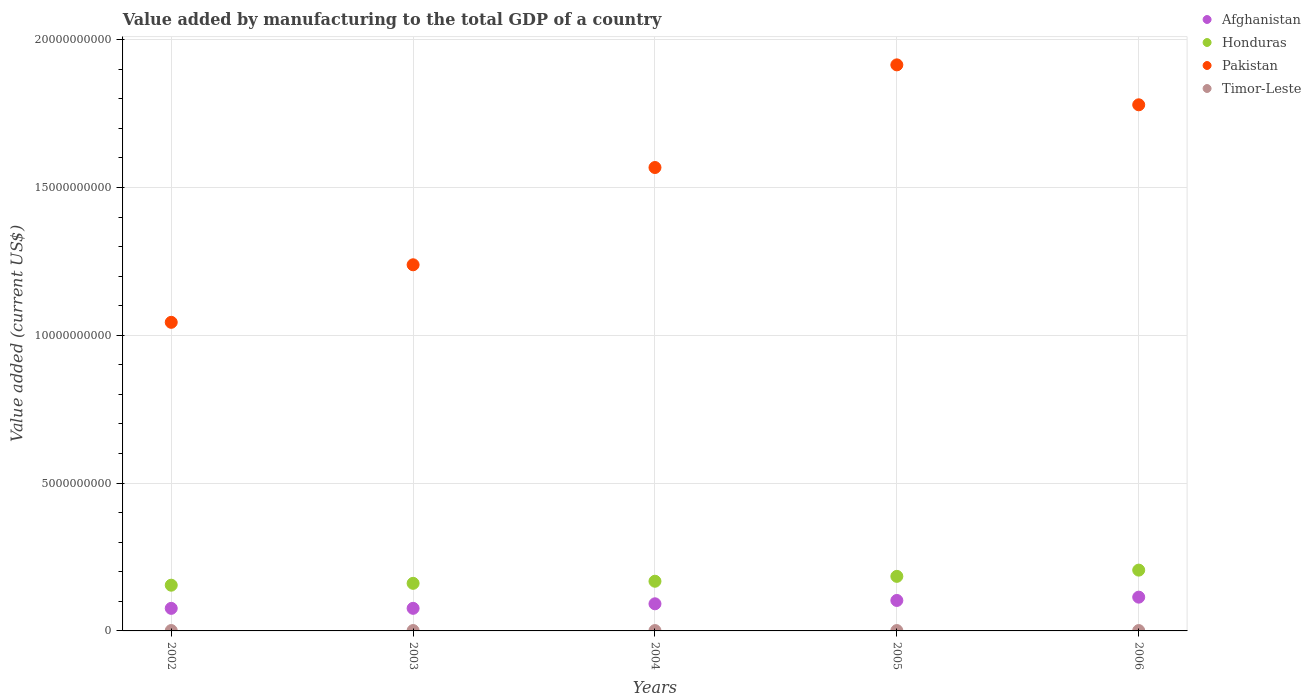How many different coloured dotlines are there?
Your answer should be compact. 4. What is the value added by manufacturing to the total GDP in Afghanistan in 2002?
Ensure brevity in your answer.  7.63e+08. Across all years, what is the maximum value added by manufacturing to the total GDP in Afghanistan?
Your response must be concise. 1.14e+09. Across all years, what is the minimum value added by manufacturing to the total GDP in Pakistan?
Your response must be concise. 1.04e+1. In which year was the value added by manufacturing to the total GDP in Honduras minimum?
Provide a short and direct response. 2002. What is the total value added by manufacturing to the total GDP in Honduras in the graph?
Provide a succinct answer. 8.74e+09. What is the difference between the value added by manufacturing to the total GDP in Pakistan in 2005 and that in 2006?
Your answer should be very brief. 1.35e+09. What is the difference between the value added by manufacturing to the total GDP in Timor-Leste in 2006 and the value added by manufacturing to the total GDP in Pakistan in 2004?
Ensure brevity in your answer.  -1.57e+1. What is the average value added by manufacturing to the total GDP in Pakistan per year?
Offer a terse response. 1.51e+1. In the year 2003, what is the difference between the value added by manufacturing to the total GDP in Pakistan and value added by manufacturing to the total GDP in Honduras?
Provide a succinct answer. 1.08e+1. What is the ratio of the value added by manufacturing to the total GDP in Honduras in 2004 to that in 2005?
Offer a terse response. 0.91. What is the difference between the highest and the lowest value added by manufacturing to the total GDP in Honduras?
Your response must be concise. 5.10e+08. In how many years, is the value added by manufacturing to the total GDP in Afghanistan greater than the average value added by manufacturing to the total GDP in Afghanistan taken over all years?
Give a very brief answer. 2. Is the sum of the value added by manufacturing to the total GDP in Pakistan in 2005 and 2006 greater than the maximum value added by manufacturing to the total GDP in Afghanistan across all years?
Your response must be concise. Yes. Is it the case that in every year, the sum of the value added by manufacturing to the total GDP in Afghanistan and value added by manufacturing to the total GDP in Pakistan  is greater than the sum of value added by manufacturing to the total GDP in Honduras and value added by manufacturing to the total GDP in Timor-Leste?
Make the answer very short. Yes. Is it the case that in every year, the sum of the value added by manufacturing to the total GDP in Pakistan and value added by manufacturing to the total GDP in Timor-Leste  is greater than the value added by manufacturing to the total GDP in Afghanistan?
Your answer should be compact. Yes. Is the value added by manufacturing to the total GDP in Honduras strictly greater than the value added by manufacturing to the total GDP in Pakistan over the years?
Offer a terse response. No. Is the value added by manufacturing to the total GDP in Timor-Leste strictly less than the value added by manufacturing to the total GDP in Pakistan over the years?
Offer a terse response. Yes. How many years are there in the graph?
Your response must be concise. 5. Are the values on the major ticks of Y-axis written in scientific E-notation?
Make the answer very short. No. Does the graph contain grids?
Your answer should be very brief. Yes. How are the legend labels stacked?
Offer a very short reply. Vertical. What is the title of the graph?
Provide a short and direct response. Value added by manufacturing to the total GDP of a country. Does "Albania" appear as one of the legend labels in the graph?
Your answer should be very brief. No. What is the label or title of the X-axis?
Provide a succinct answer. Years. What is the label or title of the Y-axis?
Offer a terse response. Value added (current US$). What is the Value added (current US$) in Afghanistan in 2002?
Provide a short and direct response. 7.63e+08. What is the Value added (current US$) in Honduras in 2002?
Provide a succinct answer. 1.55e+09. What is the Value added (current US$) in Pakistan in 2002?
Make the answer very short. 1.04e+1. What is the Value added (current US$) in Timor-Leste in 2002?
Ensure brevity in your answer.  1.30e+07. What is the Value added (current US$) in Afghanistan in 2003?
Your response must be concise. 7.64e+08. What is the Value added (current US$) of Honduras in 2003?
Offer a very short reply. 1.61e+09. What is the Value added (current US$) of Pakistan in 2003?
Make the answer very short. 1.24e+1. What is the Value added (current US$) in Timor-Leste in 2003?
Provide a short and direct response. 1.30e+07. What is the Value added (current US$) of Afghanistan in 2004?
Offer a terse response. 9.18e+08. What is the Value added (current US$) in Honduras in 2004?
Your answer should be compact. 1.68e+09. What is the Value added (current US$) of Pakistan in 2004?
Offer a terse response. 1.57e+1. What is the Value added (current US$) of Timor-Leste in 2004?
Keep it short and to the point. 1.20e+07. What is the Value added (current US$) in Afghanistan in 2005?
Provide a short and direct response. 1.03e+09. What is the Value added (current US$) in Honduras in 2005?
Keep it short and to the point. 1.85e+09. What is the Value added (current US$) in Pakistan in 2005?
Offer a terse response. 1.91e+1. What is the Value added (current US$) of Timor-Leste in 2005?
Offer a terse response. 1.20e+07. What is the Value added (current US$) of Afghanistan in 2006?
Provide a succinct answer. 1.14e+09. What is the Value added (current US$) of Honduras in 2006?
Your answer should be very brief. 2.06e+09. What is the Value added (current US$) in Pakistan in 2006?
Your answer should be very brief. 1.78e+1. Across all years, what is the maximum Value added (current US$) of Afghanistan?
Keep it short and to the point. 1.14e+09. Across all years, what is the maximum Value added (current US$) in Honduras?
Offer a very short reply. 2.06e+09. Across all years, what is the maximum Value added (current US$) in Pakistan?
Offer a terse response. 1.91e+1. Across all years, what is the maximum Value added (current US$) of Timor-Leste?
Your answer should be very brief. 1.30e+07. Across all years, what is the minimum Value added (current US$) of Afghanistan?
Keep it short and to the point. 7.63e+08. Across all years, what is the minimum Value added (current US$) of Honduras?
Keep it short and to the point. 1.55e+09. Across all years, what is the minimum Value added (current US$) of Pakistan?
Keep it short and to the point. 1.04e+1. What is the total Value added (current US$) of Afghanistan in the graph?
Make the answer very short. 4.62e+09. What is the total Value added (current US$) of Honduras in the graph?
Offer a terse response. 8.74e+09. What is the total Value added (current US$) of Pakistan in the graph?
Your answer should be very brief. 7.54e+1. What is the total Value added (current US$) in Timor-Leste in the graph?
Make the answer very short. 6.20e+07. What is the difference between the Value added (current US$) of Afghanistan in 2002 and that in 2003?
Offer a very short reply. -9.11e+05. What is the difference between the Value added (current US$) in Honduras in 2002 and that in 2003?
Your answer should be compact. -6.28e+07. What is the difference between the Value added (current US$) in Pakistan in 2002 and that in 2003?
Provide a succinct answer. -1.95e+09. What is the difference between the Value added (current US$) of Timor-Leste in 2002 and that in 2003?
Provide a short and direct response. 0. What is the difference between the Value added (current US$) of Afghanistan in 2002 and that in 2004?
Provide a succinct answer. -1.54e+08. What is the difference between the Value added (current US$) of Honduras in 2002 and that in 2004?
Your answer should be compact. -1.34e+08. What is the difference between the Value added (current US$) in Pakistan in 2002 and that in 2004?
Make the answer very short. -5.24e+09. What is the difference between the Value added (current US$) in Timor-Leste in 2002 and that in 2004?
Give a very brief answer. 1.00e+06. What is the difference between the Value added (current US$) in Afghanistan in 2002 and that in 2005?
Your answer should be very brief. -2.67e+08. What is the difference between the Value added (current US$) in Honduras in 2002 and that in 2005?
Your answer should be compact. -2.99e+08. What is the difference between the Value added (current US$) in Pakistan in 2002 and that in 2005?
Your answer should be very brief. -8.71e+09. What is the difference between the Value added (current US$) in Timor-Leste in 2002 and that in 2005?
Provide a short and direct response. 1.00e+06. What is the difference between the Value added (current US$) in Afghanistan in 2002 and that in 2006?
Provide a short and direct response. -3.79e+08. What is the difference between the Value added (current US$) in Honduras in 2002 and that in 2006?
Make the answer very short. -5.10e+08. What is the difference between the Value added (current US$) of Pakistan in 2002 and that in 2006?
Your answer should be compact. -7.36e+09. What is the difference between the Value added (current US$) in Afghanistan in 2003 and that in 2004?
Offer a very short reply. -1.53e+08. What is the difference between the Value added (current US$) of Honduras in 2003 and that in 2004?
Your answer should be compact. -7.09e+07. What is the difference between the Value added (current US$) in Pakistan in 2003 and that in 2004?
Your answer should be compact. -3.29e+09. What is the difference between the Value added (current US$) of Timor-Leste in 2003 and that in 2004?
Provide a succinct answer. 1.00e+06. What is the difference between the Value added (current US$) of Afghanistan in 2003 and that in 2005?
Provide a short and direct response. -2.66e+08. What is the difference between the Value added (current US$) in Honduras in 2003 and that in 2005?
Your answer should be very brief. -2.36e+08. What is the difference between the Value added (current US$) of Pakistan in 2003 and that in 2005?
Give a very brief answer. -6.76e+09. What is the difference between the Value added (current US$) of Timor-Leste in 2003 and that in 2005?
Provide a short and direct response. 1.00e+06. What is the difference between the Value added (current US$) in Afghanistan in 2003 and that in 2006?
Ensure brevity in your answer.  -3.78e+08. What is the difference between the Value added (current US$) in Honduras in 2003 and that in 2006?
Offer a very short reply. -4.47e+08. What is the difference between the Value added (current US$) of Pakistan in 2003 and that in 2006?
Offer a very short reply. -5.41e+09. What is the difference between the Value added (current US$) in Timor-Leste in 2003 and that in 2006?
Your answer should be compact. 1.00e+06. What is the difference between the Value added (current US$) in Afghanistan in 2004 and that in 2005?
Provide a short and direct response. -1.13e+08. What is the difference between the Value added (current US$) in Honduras in 2004 and that in 2005?
Offer a terse response. -1.65e+08. What is the difference between the Value added (current US$) of Pakistan in 2004 and that in 2005?
Your answer should be very brief. -3.47e+09. What is the difference between the Value added (current US$) in Afghanistan in 2004 and that in 2006?
Your response must be concise. -2.25e+08. What is the difference between the Value added (current US$) in Honduras in 2004 and that in 2006?
Your response must be concise. -3.76e+08. What is the difference between the Value added (current US$) in Pakistan in 2004 and that in 2006?
Ensure brevity in your answer.  -2.12e+09. What is the difference between the Value added (current US$) in Afghanistan in 2005 and that in 2006?
Your response must be concise. -1.12e+08. What is the difference between the Value added (current US$) of Honduras in 2005 and that in 2006?
Ensure brevity in your answer.  -2.11e+08. What is the difference between the Value added (current US$) of Pakistan in 2005 and that in 2006?
Give a very brief answer. 1.35e+09. What is the difference between the Value added (current US$) of Afghanistan in 2002 and the Value added (current US$) of Honduras in 2003?
Your answer should be very brief. -8.46e+08. What is the difference between the Value added (current US$) in Afghanistan in 2002 and the Value added (current US$) in Pakistan in 2003?
Your response must be concise. -1.16e+1. What is the difference between the Value added (current US$) in Afghanistan in 2002 and the Value added (current US$) in Timor-Leste in 2003?
Your answer should be compact. 7.50e+08. What is the difference between the Value added (current US$) of Honduras in 2002 and the Value added (current US$) of Pakistan in 2003?
Offer a terse response. -1.08e+1. What is the difference between the Value added (current US$) of Honduras in 2002 and the Value added (current US$) of Timor-Leste in 2003?
Provide a succinct answer. 1.53e+09. What is the difference between the Value added (current US$) of Pakistan in 2002 and the Value added (current US$) of Timor-Leste in 2003?
Provide a short and direct response. 1.04e+1. What is the difference between the Value added (current US$) of Afghanistan in 2002 and the Value added (current US$) of Honduras in 2004?
Offer a terse response. -9.17e+08. What is the difference between the Value added (current US$) in Afghanistan in 2002 and the Value added (current US$) in Pakistan in 2004?
Your answer should be very brief. -1.49e+1. What is the difference between the Value added (current US$) in Afghanistan in 2002 and the Value added (current US$) in Timor-Leste in 2004?
Give a very brief answer. 7.51e+08. What is the difference between the Value added (current US$) of Honduras in 2002 and the Value added (current US$) of Pakistan in 2004?
Offer a very short reply. -1.41e+1. What is the difference between the Value added (current US$) in Honduras in 2002 and the Value added (current US$) in Timor-Leste in 2004?
Provide a short and direct response. 1.53e+09. What is the difference between the Value added (current US$) in Pakistan in 2002 and the Value added (current US$) in Timor-Leste in 2004?
Provide a short and direct response. 1.04e+1. What is the difference between the Value added (current US$) in Afghanistan in 2002 and the Value added (current US$) in Honduras in 2005?
Make the answer very short. -1.08e+09. What is the difference between the Value added (current US$) of Afghanistan in 2002 and the Value added (current US$) of Pakistan in 2005?
Offer a very short reply. -1.84e+1. What is the difference between the Value added (current US$) in Afghanistan in 2002 and the Value added (current US$) in Timor-Leste in 2005?
Ensure brevity in your answer.  7.51e+08. What is the difference between the Value added (current US$) in Honduras in 2002 and the Value added (current US$) in Pakistan in 2005?
Ensure brevity in your answer.  -1.76e+1. What is the difference between the Value added (current US$) in Honduras in 2002 and the Value added (current US$) in Timor-Leste in 2005?
Ensure brevity in your answer.  1.53e+09. What is the difference between the Value added (current US$) in Pakistan in 2002 and the Value added (current US$) in Timor-Leste in 2005?
Make the answer very short. 1.04e+1. What is the difference between the Value added (current US$) in Afghanistan in 2002 and the Value added (current US$) in Honduras in 2006?
Offer a terse response. -1.29e+09. What is the difference between the Value added (current US$) of Afghanistan in 2002 and the Value added (current US$) of Pakistan in 2006?
Your answer should be very brief. -1.70e+1. What is the difference between the Value added (current US$) in Afghanistan in 2002 and the Value added (current US$) in Timor-Leste in 2006?
Your response must be concise. 7.51e+08. What is the difference between the Value added (current US$) in Honduras in 2002 and the Value added (current US$) in Pakistan in 2006?
Ensure brevity in your answer.  -1.63e+1. What is the difference between the Value added (current US$) in Honduras in 2002 and the Value added (current US$) in Timor-Leste in 2006?
Your answer should be compact. 1.53e+09. What is the difference between the Value added (current US$) of Pakistan in 2002 and the Value added (current US$) of Timor-Leste in 2006?
Keep it short and to the point. 1.04e+1. What is the difference between the Value added (current US$) in Afghanistan in 2003 and the Value added (current US$) in Honduras in 2004?
Provide a succinct answer. -9.16e+08. What is the difference between the Value added (current US$) of Afghanistan in 2003 and the Value added (current US$) of Pakistan in 2004?
Give a very brief answer. -1.49e+1. What is the difference between the Value added (current US$) in Afghanistan in 2003 and the Value added (current US$) in Timor-Leste in 2004?
Your response must be concise. 7.52e+08. What is the difference between the Value added (current US$) of Honduras in 2003 and the Value added (current US$) of Pakistan in 2004?
Your answer should be very brief. -1.41e+1. What is the difference between the Value added (current US$) of Honduras in 2003 and the Value added (current US$) of Timor-Leste in 2004?
Offer a very short reply. 1.60e+09. What is the difference between the Value added (current US$) of Pakistan in 2003 and the Value added (current US$) of Timor-Leste in 2004?
Make the answer very short. 1.24e+1. What is the difference between the Value added (current US$) in Afghanistan in 2003 and the Value added (current US$) in Honduras in 2005?
Keep it short and to the point. -1.08e+09. What is the difference between the Value added (current US$) of Afghanistan in 2003 and the Value added (current US$) of Pakistan in 2005?
Provide a short and direct response. -1.84e+1. What is the difference between the Value added (current US$) of Afghanistan in 2003 and the Value added (current US$) of Timor-Leste in 2005?
Give a very brief answer. 7.52e+08. What is the difference between the Value added (current US$) in Honduras in 2003 and the Value added (current US$) in Pakistan in 2005?
Your answer should be very brief. -1.75e+1. What is the difference between the Value added (current US$) of Honduras in 2003 and the Value added (current US$) of Timor-Leste in 2005?
Give a very brief answer. 1.60e+09. What is the difference between the Value added (current US$) in Pakistan in 2003 and the Value added (current US$) in Timor-Leste in 2005?
Your answer should be very brief. 1.24e+1. What is the difference between the Value added (current US$) in Afghanistan in 2003 and the Value added (current US$) in Honduras in 2006?
Keep it short and to the point. -1.29e+09. What is the difference between the Value added (current US$) of Afghanistan in 2003 and the Value added (current US$) of Pakistan in 2006?
Your answer should be compact. -1.70e+1. What is the difference between the Value added (current US$) of Afghanistan in 2003 and the Value added (current US$) of Timor-Leste in 2006?
Your response must be concise. 7.52e+08. What is the difference between the Value added (current US$) of Honduras in 2003 and the Value added (current US$) of Pakistan in 2006?
Ensure brevity in your answer.  -1.62e+1. What is the difference between the Value added (current US$) of Honduras in 2003 and the Value added (current US$) of Timor-Leste in 2006?
Provide a succinct answer. 1.60e+09. What is the difference between the Value added (current US$) of Pakistan in 2003 and the Value added (current US$) of Timor-Leste in 2006?
Give a very brief answer. 1.24e+1. What is the difference between the Value added (current US$) in Afghanistan in 2004 and the Value added (current US$) in Honduras in 2005?
Offer a terse response. -9.28e+08. What is the difference between the Value added (current US$) of Afghanistan in 2004 and the Value added (current US$) of Pakistan in 2005?
Offer a very short reply. -1.82e+1. What is the difference between the Value added (current US$) in Afghanistan in 2004 and the Value added (current US$) in Timor-Leste in 2005?
Make the answer very short. 9.06e+08. What is the difference between the Value added (current US$) in Honduras in 2004 and the Value added (current US$) in Pakistan in 2005?
Your answer should be compact. -1.75e+1. What is the difference between the Value added (current US$) in Honduras in 2004 and the Value added (current US$) in Timor-Leste in 2005?
Your answer should be compact. 1.67e+09. What is the difference between the Value added (current US$) in Pakistan in 2004 and the Value added (current US$) in Timor-Leste in 2005?
Offer a very short reply. 1.57e+1. What is the difference between the Value added (current US$) of Afghanistan in 2004 and the Value added (current US$) of Honduras in 2006?
Provide a succinct answer. -1.14e+09. What is the difference between the Value added (current US$) of Afghanistan in 2004 and the Value added (current US$) of Pakistan in 2006?
Give a very brief answer. -1.69e+1. What is the difference between the Value added (current US$) of Afghanistan in 2004 and the Value added (current US$) of Timor-Leste in 2006?
Your answer should be compact. 9.06e+08. What is the difference between the Value added (current US$) of Honduras in 2004 and the Value added (current US$) of Pakistan in 2006?
Provide a succinct answer. -1.61e+1. What is the difference between the Value added (current US$) in Honduras in 2004 and the Value added (current US$) in Timor-Leste in 2006?
Offer a very short reply. 1.67e+09. What is the difference between the Value added (current US$) in Pakistan in 2004 and the Value added (current US$) in Timor-Leste in 2006?
Offer a terse response. 1.57e+1. What is the difference between the Value added (current US$) of Afghanistan in 2005 and the Value added (current US$) of Honduras in 2006?
Offer a very short reply. -1.03e+09. What is the difference between the Value added (current US$) in Afghanistan in 2005 and the Value added (current US$) in Pakistan in 2006?
Make the answer very short. -1.68e+1. What is the difference between the Value added (current US$) of Afghanistan in 2005 and the Value added (current US$) of Timor-Leste in 2006?
Ensure brevity in your answer.  1.02e+09. What is the difference between the Value added (current US$) of Honduras in 2005 and the Value added (current US$) of Pakistan in 2006?
Keep it short and to the point. -1.60e+1. What is the difference between the Value added (current US$) in Honduras in 2005 and the Value added (current US$) in Timor-Leste in 2006?
Offer a very short reply. 1.83e+09. What is the difference between the Value added (current US$) in Pakistan in 2005 and the Value added (current US$) in Timor-Leste in 2006?
Your answer should be very brief. 1.91e+1. What is the average Value added (current US$) of Afghanistan per year?
Give a very brief answer. 9.24e+08. What is the average Value added (current US$) in Honduras per year?
Ensure brevity in your answer.  1.75e+09. What is the average Value added (current US$) in Pakistan per year?
Your response must be concise. 1.51e+1. What is the average Value added (current US$) of Timor-Leste per year?
Give a very brief answer. 1.24e+07. In the year 2002, what is the difference between the Value added (current US$) of Afghanistan and Value added (current US$) of Honduras?
Give a very brief answer. -7.84e+08. In the year 2002, what is the difference between the Value added (current US$) in Afghanistan and Value added (current US$) in Pakistan?
Make the answer very short. -9.68e+09. In the year 2002, what is the difference between the Value added (current US$) in Afghanistan and Value added (current US$) in Timor-Leste?
Give a very brief answer. 7.50e+08. In the year 2002, what is the difference between the Value added (current US$) in Honduras and Value added (current US$) in Pakistan?
Make the answer very short. -8.89e+09. In the year 2002, what is the difference between the Value added (current US$) in Honduras and Value added (current US$) in Timor-Leste?
Your answer should be very brief. 1.53e+09. In the year 2002, what is the difference between the Value added (current US$) in Pakistan and Value added (current US$) in Timor-Leste?
Provide a succinct answer. 1.04e+1. In the year 2003, what is the difference between the Value added (current US$) in Afghanistan and Value added (current US$) in Honduras?
Ensure brevity in your answer.  -8.45e+08. In the year 2003, what is the difference between the Value added (current US$) in Afghanistan and Value added (current US$) in Pakistan?
Provide a short and direct response. -1.16e+1. In the year 2003, what is the difference between the Value added (current US$) of Afghanistan and Value added (current US$) of Timor-Leste?
Keep it short and to the point. 7.51e+08. In the year 2003, what is the difference between the Value added (current US$) in Honduras and Value added (current US$) in Pakistan?
Your response must be concise. -1.08e+1. In the year 2003, what is the difference between the Value added (current US$) in Honduras and Value added (current US$) in Timor-Leste?
Ensure brevity in your answer.  1.60e+09. In the year 2003, what is the difference between the Value added (current US$) in Pakistan and Value added (current US$) in Timor-Leste?
Give a very brief answer. 1.24e+1. In the year 2004, what is the difference between the Value added (current US$) of Afghanistan and Value added (current US$) of Honduras?
Give a very brief answer. -7.63e+08. In the year 2004, what is the difference between the Value added (current US$) in Afghanistan and Value added (current US$) in Pakistan?
Provide a short and direct response. -1.48e+1. In the year 2004, what is the difference between the Value added (current US$) of Afghanistan and Value added (current US$) of Timor-Leste?
Make the answer very short. 9.06e+08. In the year 2004, what is the difference between the Value added (current US$) of Honduras and Value added (current US$) of Pakistan?
Your answer should be very brief. -1.40e+1. In the year 2004, what is the difference between the Value added (current US$) in Honduras and Value added (current US$) in Timor-Leste?
Provide a succinct answer. 1.67e+09. In the year 2004, what is the difference between the Value added (current US$) of Pakistan and Value added (current US$) of Timor-Leste?
Keep it short and to the point. 1.57e+1. In the year 2005, what is the difference between the Value added (current US$) in Afghanistan and Value added (current US$) in Honduras?
Keep it short and to the point. -8.15e+08. In the year 2005, what is the difference between the Value added (current US$) in Afghanistan and Value added (current US$) in Pakistan?
Keep it short and to the point. -1.81e+1. In the year 2005, what is the difference between the Value added (current US$) of Afghanistan and Value added (current US$) of Timor-Leste?
Provide a short and direct response. 1.02e+09. In the year 2005, what is the difference between the Value added (current US$) of Honduras and Value added (current US$) of Pakistan?
Provide a succinct answer. -1.73e+1. In the year 2005, what is the difference between the Value added (current US$) of Honduras and Value added (current US$) of Timor-Leste?
Make the answer very short. 1.83e+09. In the year 2005, what is the difference between the Value added (current US$) of Pakistan and Value added (current US$) of Timor-Leste?
Provide a succinct answer. 1.91e+1. In the year 2006, what is the difference between the Value added (current US$) in Afghanistan and Value added (current US$) in Honduras?
Ensure brevity in your answer.  -9.14e+08. In the year 2006, what is the difference between the Value added (current US$) in Afghanistan and Value added (current US$) in Pakistan?
Provide a succinct answer. -1.67e+1. In the year 2006, what is the difference between the Value added (current US$) in Afghanistan and Value added (current US$) in Timor-Leste?
Provide a short and direct response. 1.13e+09. In the year 2006, what is the difference between the Value added (current US$) in Honduras and Value added (current US$) in Pakistan?
Your response must be concise. -1.57e+1. In the year 2006, what is the difference between the Value added (current US$) in Honduras and Value added (current US$) in Timor-Leste?
Make the answer very short. 2.04e+09. In the year 2006, what is the difference between the Value added (current US$) of Pakistan and Value added (current US$) of Timor-Leste?
Make the answer very short. 1.78e+1. What is the ratio of the Value added (current US$) in Pakistan in 2002 to that in 2003?
Provide a short and direct response. 0.84. What is the ratio of the Value added (current US$) in Timor-Leste in 2002 to that in 2003?
Offer a terse response. 1. What is the ratio of the Value added (current US$) of Afghanistan in 2002 to that in 2004?
Your answer should be very brief. 0.83. What is the ratio of the Value added (current US$) in Honduras in 2002 to that in 2004?
Your answer should be compact. 0.92. What is the ratio of the Value added (current US$) in Pakistan in 2002 to that in 2004?
Offer a very short reply. 0.67. What is the ratio of the Value added (current US$) of Timor-Leste in 2002 to that in 2004?
Provide a succinct answer. 1.08. What is the ratio of the Value added (current US$) in Afghanistan in 2002 to that in 2005?
Ensure brevity in your answer.  0.74. What is the ratio of the Value added (current US$) in Honduras in 2002 to that in 2005?
Give a very brief answer. 0.84. What is the ratio of the Value added (current US$) of Pakistan in 2002 to that in 2005?
Offer a terse response. 0.55. What is the ratio of the Value added (current US$) of Afghanistan in 2002 to that in 2006?
Make the answer very short. 0.67. What is the ratio of the Value added (current US$) of Honduras in 2002 to that in 2006?
Your answer should be compact. 0.75. What is the ratio of the Value added (current US$) in Pakistan in 2002 to that in 2006?
Your response must be concise. 0.59. What is the ratio of the Value added (current US$) of Afghanistan in 2003 to that in 2004?
Provide a succinct answer. 0.83. What is the ratio of the Value added (current US$) in Honduras in 2003 to that in 2004?
Your response must be concise. 0.96. What is the ratio of the Value added (current US$) of Pakistan in 2003 to that in 2004?
Keep it short and to the point. 0.79. What is the ratio of the Value added (current US$) of Afghanistan in 2003 to that in 2005?
Offer a very short reply. 0.74. What is the ratio of the Value added (current US$) of Honduras in 2003 to that in 2005?
Provide a short and direct response. 0.87. What is the ratio of the Value added (current US$) in Pakistan in 2003 to that in 2005?
Provide a succinct answer. 0.65. What is the ratio of the Value added (current US$) of Timor-Leste in 2003 to that in 2005?
Offer a terse response. 1.08. What is the ratio of the Value added (current US$) in Afghanistan in 2003 to that in 2006?
Provide a succinct answer. 0.67. What is the ratio of the Value added (current US$) of Honduras in 2003 to that in 2006?
Offer a terse response. 0.78. What is the ratio of the Value added (current US$) of Pakistan in 2003 to that in 2006?
Keep it short and to the point. 0.7. What is the ratio of the Value added (current US$) in Timor-Leste in 2003 to that in 2006?
Give a very brief answer. 1.08. What is the ratio of the Value added (current US$) of Afghanistan in 2004 to that in 2005?
Ensure brevity in your answer.  0.89. What is the ratio of the Value added (current US$) of Honduras in 2004 to that in 2005?
Offer a very short reply. 0.91. What is the ratio of the Value added (current US$) of Pakistan in 2004 to that in 2005?
Make the answer very short. 0.82. What is the ratio of the Value added (current US$) of Timor-Leste in 2004 to that in 2005?
Provide a short and direct response. 1. What is the ratio of the Value added (current US$) of Afghanistan in 2004 to that in 2006?
Ensure brevity in your answer.  0.8. What is the ratio of the Value added (current US$) of Honduras in 2004 to that in 2006?
Your answer should be compact. 0.82. What is the ratio of the Value added (current US$) of Pakistan in 2004 to that in 2006?
Ensure brevity in your answer.  0.88. What is the ratio of the Value added (current US$) in Afghanistan in 2005 to that in 2006?
Offer a terse response. 0.9. What is the ratio of the Value added (current US$) in Honduras in 2005 to that in 2006?
Give a very brief answer. 0.9. What is the ratio of the Value added (current US$) in Pakistan in 2005 to that in 2006?
Your response must be concise. 1.08. What is the difference between the highest and the second highest Value added (current US$) of Afghanistan?
Your response must be concise. 1.12e+08. What is the difference between the highest and the second highest Value added (current US$) in Honduras?
Provide a succinct answer. 2.11e+08. What is the difference between the highest and the second highest Value added (current US$) in Pakistan?
Offer a terse response. 1.35e+09. What is the difference between the highest and the lowest Value added (current US$) in Afghanistan?
Offer a very short reply. 3.79e+08. What is the difference between the highest and the lowest Value added (current US$) of Honduras?
Give a very brief answer. 5.10e+08. What is the difference between the highest and the lowest Value added (current US$) in Pakistan?
Keep it short and to the point. 8.71e+09. What is the difference between the highest and the lowest Value added (current US$) in Timor-Leste?
Make the answer very short. 1.00e+06. 